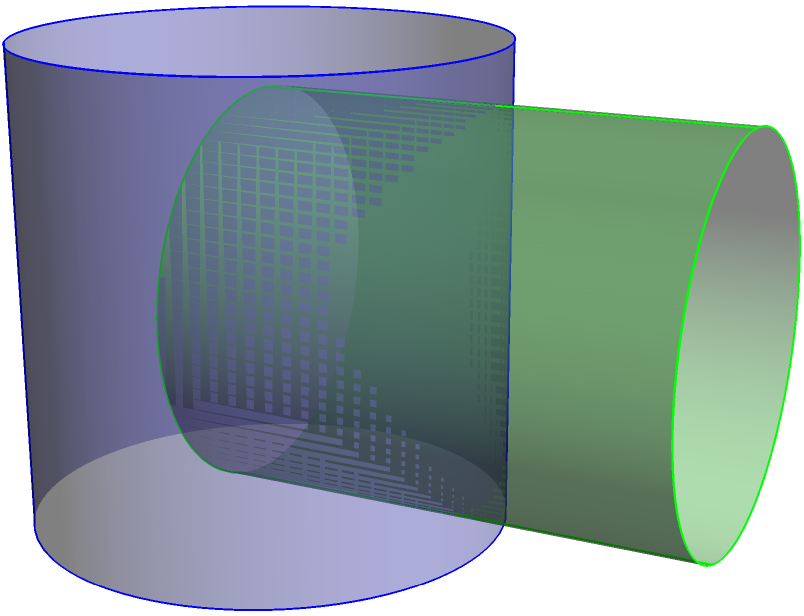Imagine you're trying to create a unique waterproof housing for your GoPro camera. You decide to use the intersection of two cylinders as a starting point. The main cylinder (representing the camera body) has a radius of 1 inch and a height of 2 inches. A second cylinder (representing a lens attachment) intersects it perpendicularly, with a radius of 0.8 inches and the same height. What is the volume of the resulting intersection in cubic inches? (Use $\pi \approx 3.14$ for calculations) To find the volume of the intersection, we'll use the formula for the intersection of two perpendicular cylinders:

1) The volume formula is: $V = \frac{16}{3}r_1^2r_2 - \frac{8}{3}r_1r_2^2$

   Where $r_1$ is the radius of the larger cylinder and $r_2$ is the radius of the smaller cylinder.

2) We have:
   $r_1 = 1$ inch (main cylinder)
   $r_2 = 0.8$ inches (intersecting cylinder)

3) Let's substitute these values into the formula:

   $V = \frac{16}{3}(1)^2(0.8) - \frac{8}{3}(1)(0.8)^2$

4) Simplify:
   $V = \frac{16}{3}(0.8) - \frac{8}{3}(0.64)$
   $V = 4.267 - 1.707$
   $V = 2.56$ cubic inches

5) To get a more precise answer, we multiply by $\pi$:
   $V = 2.56 \pi \approx 2.56 * 3.14 = 8.0384$ cubic inches

Therefore, the volume of the intersection is approximately 8.04 cubic inches.
Answer: $8.04$ cubic inches 